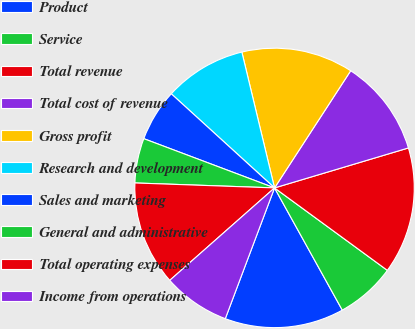<chart> <loc_0><loc_0><loc_500><loc_500><pie_chart><fcel>Product<fcel>Service<fcel>Total revenue<fcel>Total cost of revenue<fcel>Gross profit<fcel>Research and development<fcel>Sales and marketing<fcel>General and administrative<fcel>Total operating expenses<fcel>Income from operations<nl><fcel>13.79%<fcel>6.9%<fcel>14.66%<fcel>11.21%<fcel>12.93%<fcel>9.48%<fcel>6.03%<fcel>5.17%<fcel>12.07%<fcel>7.76%<nl></chart> 